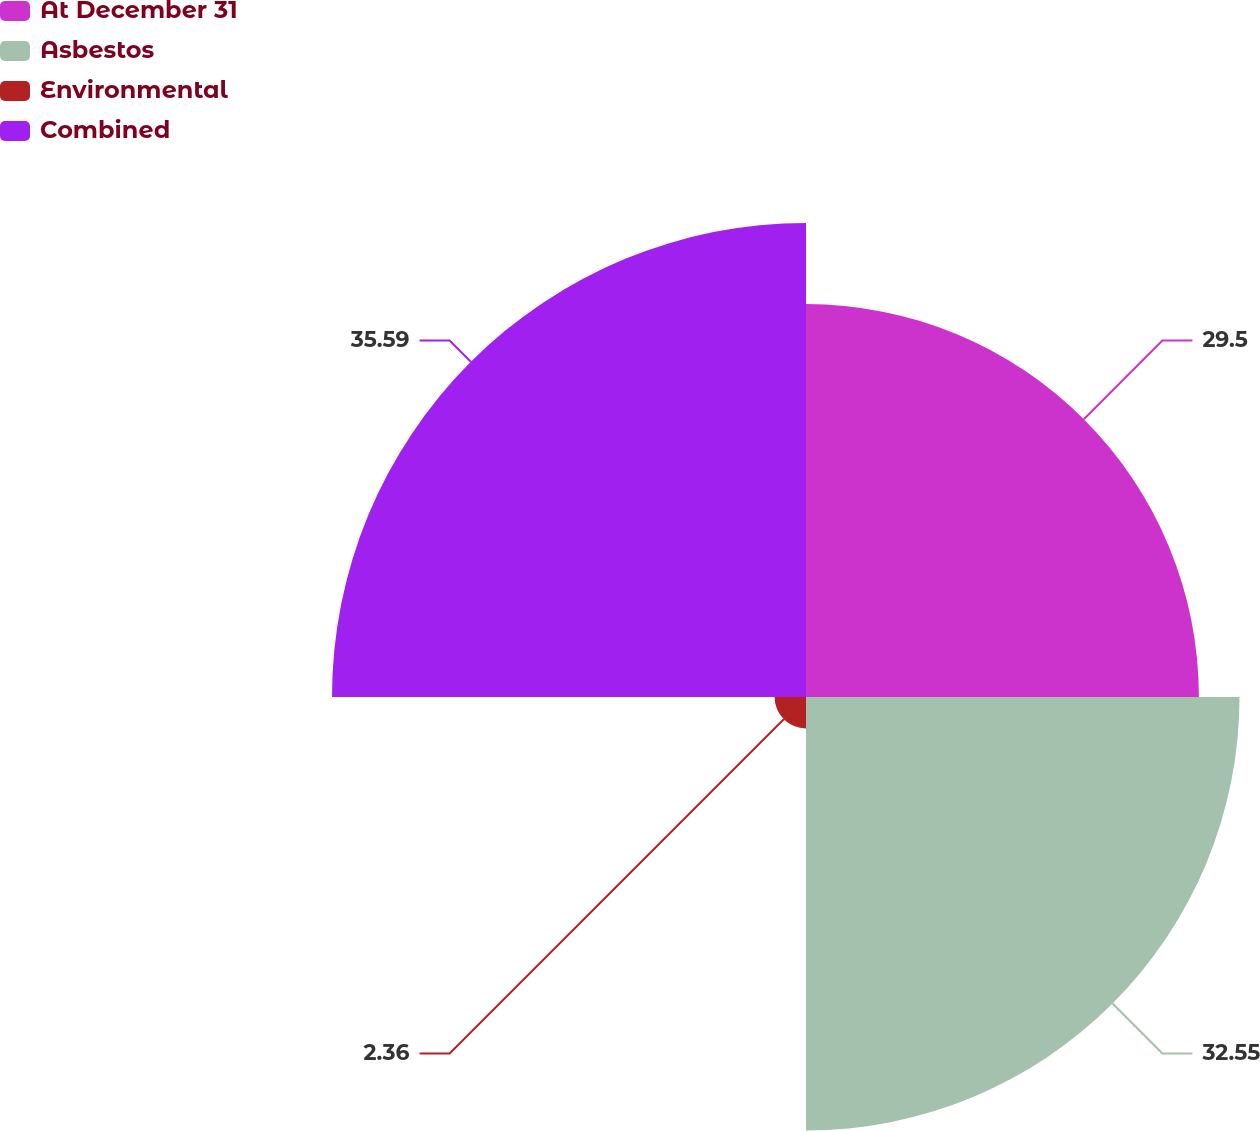<chart> <loc_0><loc_0><loc_500><loc_500><pie_chart><fcel>At December 31<fcel>Asbestos<fcel>Environmental<fcel>Combined<nl><fcel>29.5%<fcel>32.55%<fcel>2.36%<fcel>35.59%<nl></chart> 